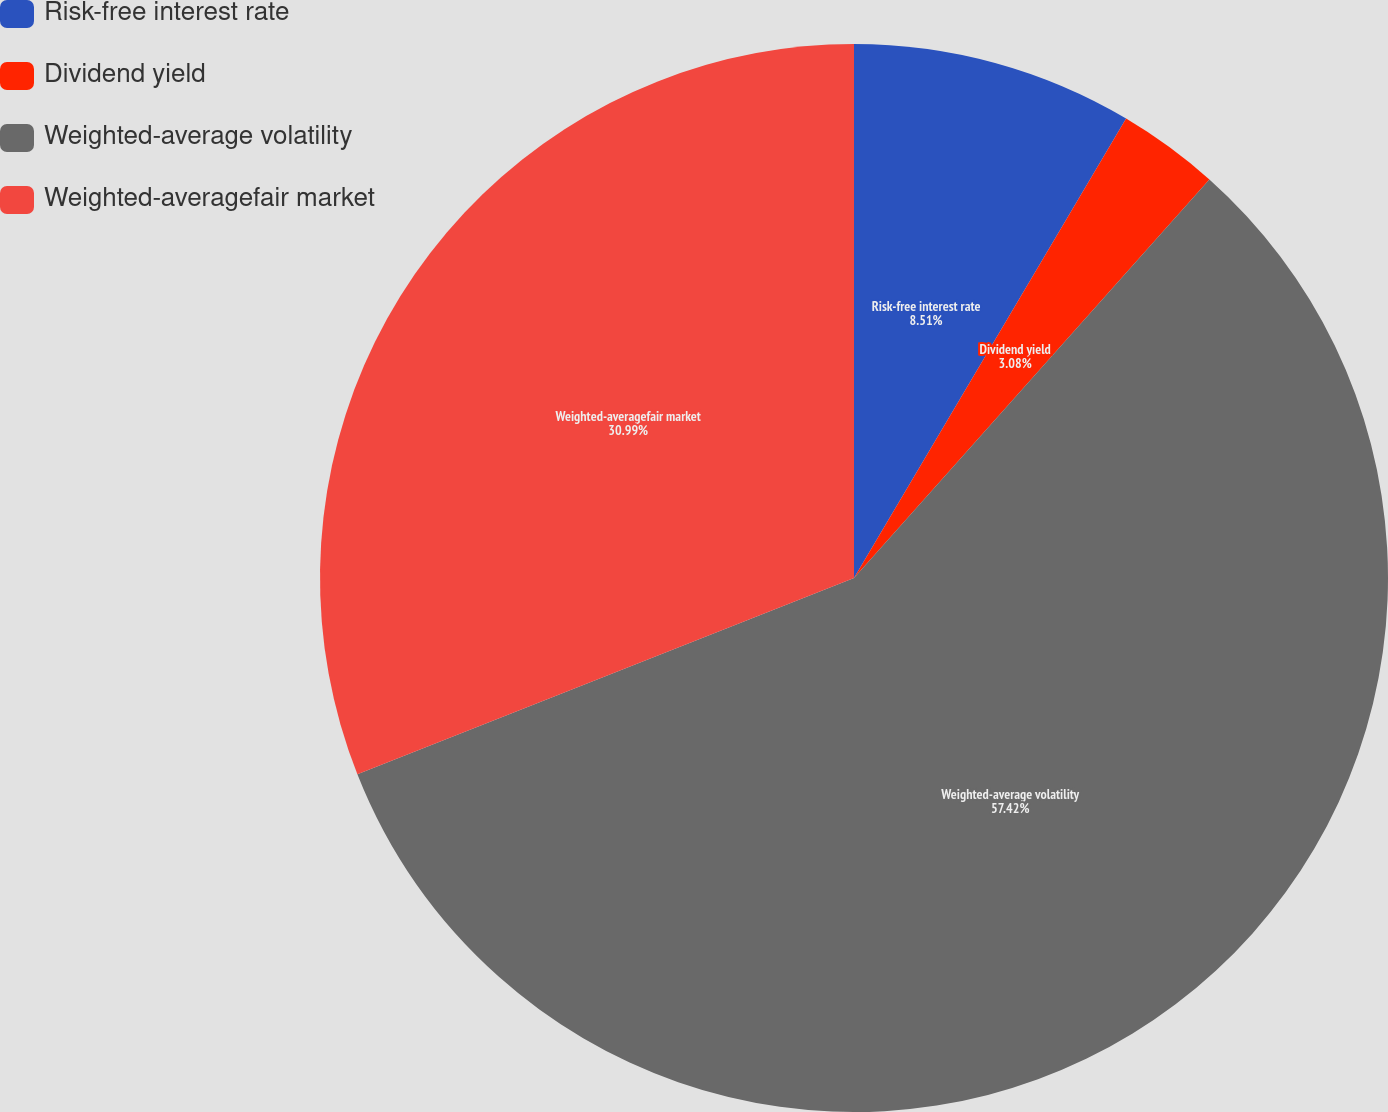Convert chart to OTSL. <chart><loc_0><loc_0><loc_500><loc_500><pie_chart><fcel>Risk-free interest rate<fcel>Dividend yield<fcel>Weighted-average volatility<fcel>Weighted-averagefair market<nl><fcel>8.51%<fcel>3.08%<fcel>57.42%<fcel>30.99%<nl></chart> 